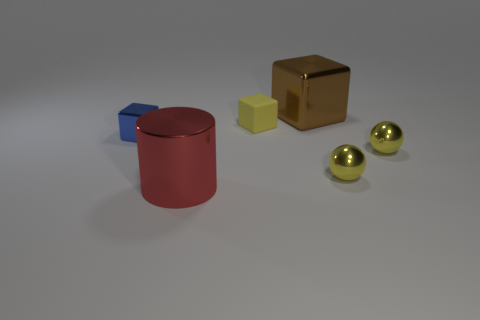The large thing behind the tiny metallic thing left of the brown metal thing is what shape?
Offer a terse response. Cube. Is there a tiny green metal sphere?
Offer a very short reply. No. There is a large metallic thing that is behind the red cylinder; what is its color?
Provide a succinct answer. Brown. There is a red thing; are there any tiny matte objects to the left of it?
Your answer should be compact. No. Is the number of metal blocks greater than the number of small things?
Offer a very short reply. No. There is a small metal thing that is to the left of the metal cube that is on the right side of the tiny shiny object to the left of the big block; what color is it?
Give a very brief answer. Blue. There is a cylinder that is made of the same material as the blue object; what is its color?
Ensure brevity in your answer.  Red. Is there anything else that is the same size as the blue block?
Provide a succinct answer. Yes. How many objects are either cubes that are left of the metallic cylinder or yellow things that are behind the small blue cube?
Provide a succinct answer. 2. There is a yellow object that is behind the small blue shiny object; does it have the same size as the block that is on the left side of the red cylinder?
Your response must be concise. Yes. 